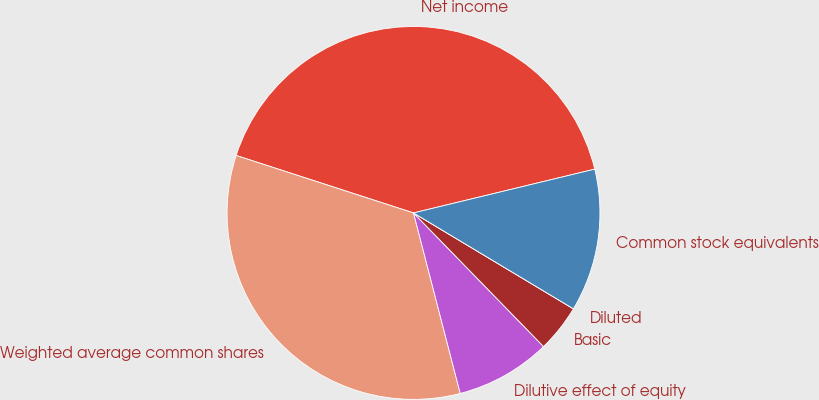<chart> <loc_0><loc_0><loc_500><loc_500><pie_chart><fcel>Net income<fcel>Weighted average common shares<fcel>Dilutive effect of equity<fcel>Basic<fcel>Diluted<fcel>Common stock equivalents<nl><fcel>41.24%<fcel>34.02%<fcel>8.25%<fcel>4.12%<fcel>0.0%<fcel>12.37%<nl></chart> 